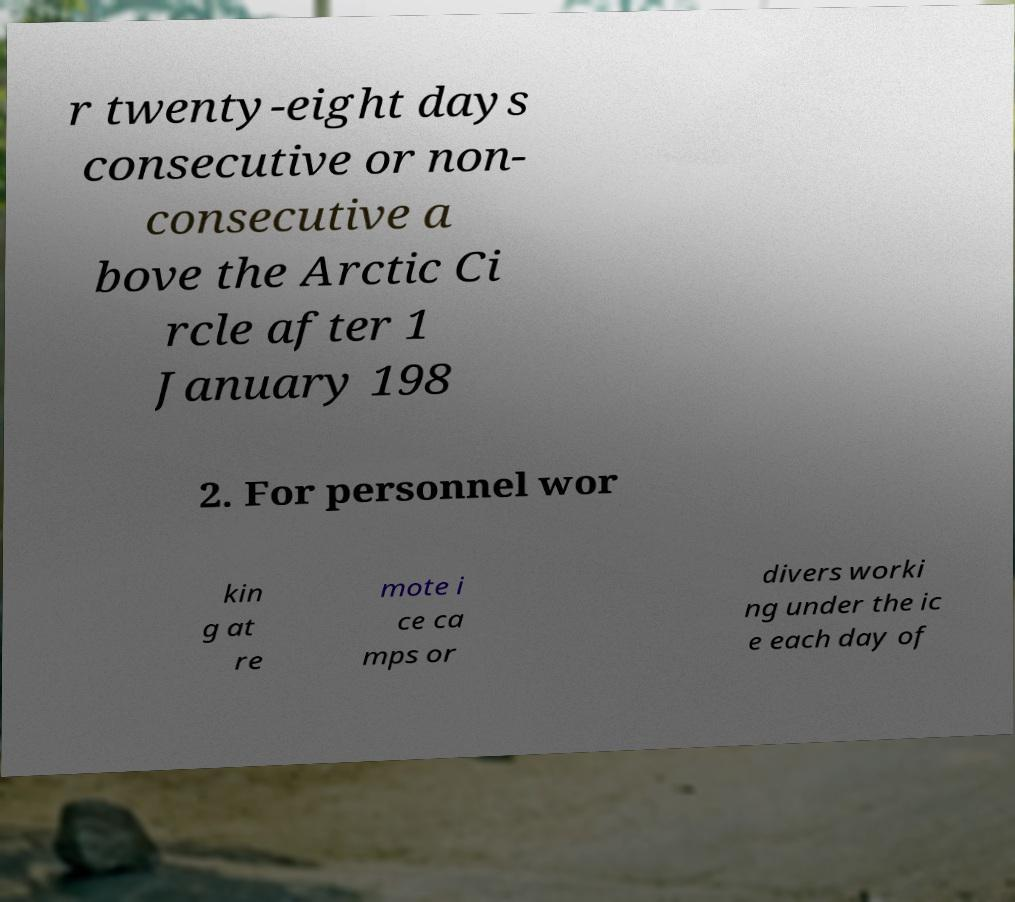Please identify and transcribe the text found in this image. r twenty-eight days consecutive or non- consecutive a bove the Arctic Ci rcle after 1 January 198 2. For personnel wor kin g at re mote i ce ca mps or divers worki ng under the ic e each day of 